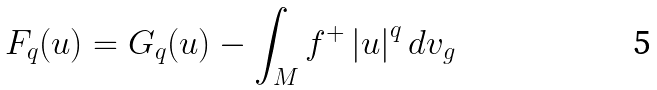<formula> <loc_0><loc_0><loc_500><loc_500>F _ { q } ( u ) = G _ { q } ( u ) - \int _ { M } f ^ { + } \left | u \right | ^ { q } d v _ { g }</formula> 